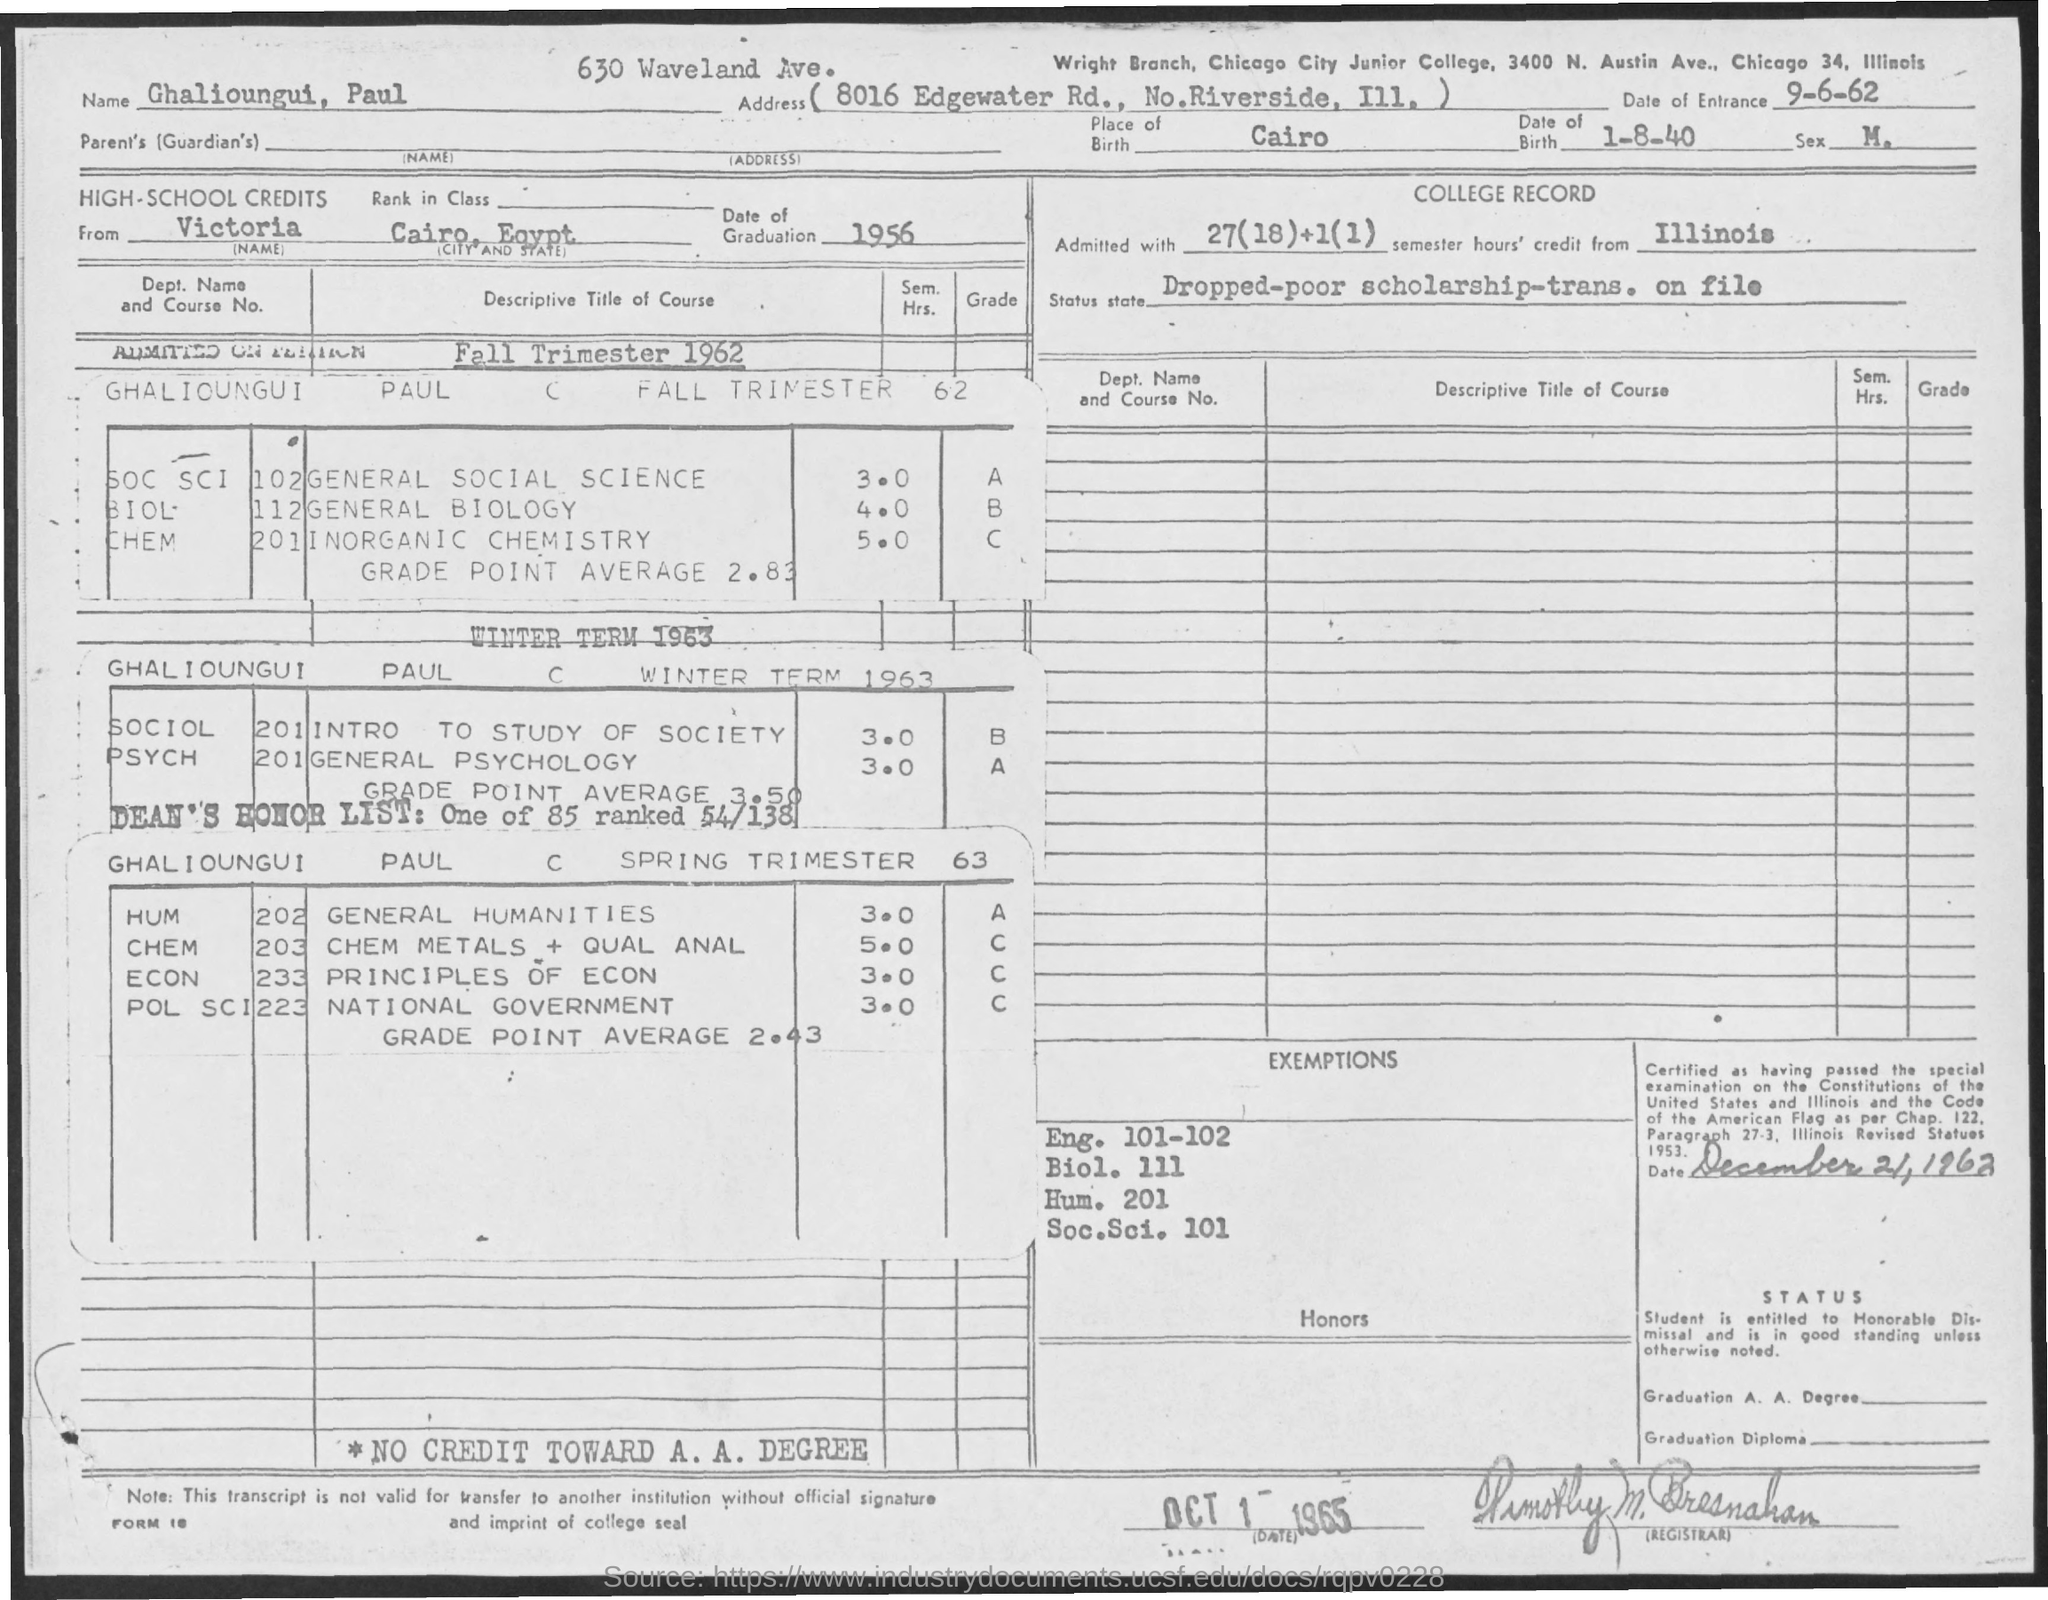List a handful of essential elements in this visual. According to the given information, it can be declared that Paul Ghalioungui graduated from high school in the year 1956. Cairo is the birthplace of Paul Ghalioungui. The document contains the date of entrance, which is September 6, 1962. On August 1st, 1940, Paul Ghalioungui was born. 